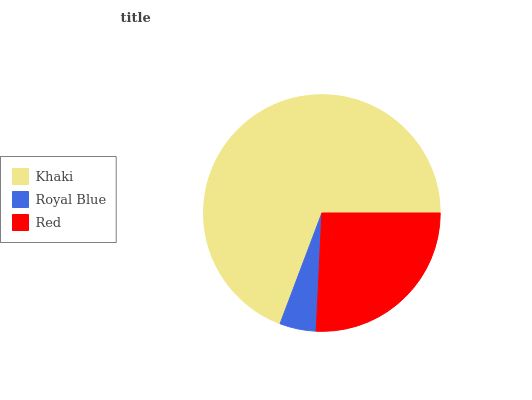Is Royal Blue the minimum?
Answer yes or no. Yes. Is Khaki the maximum?
Answer yes or no. Yes. Is Red the minimum?
Answer yes or no. No. Is Red the maximum?
Answer yes or no. No. Is Red greater than Royal Blue?
Answer yes or no. Yes. Is Royal Blue less than Red?
Answer yes or no. Yes. Is Royal Blue greater than Red?
Answer yes or no. No. Is Red less than Royal Blue?
Answer yes or no. No. Is Red the high median?
Answer yes or no. Yes. Is Red the low median?
Answer yes or no. Yes. Is Khaki the high median?
Answer yes or no. No. Is Khaki the low median?
Answer yes or no. No. 